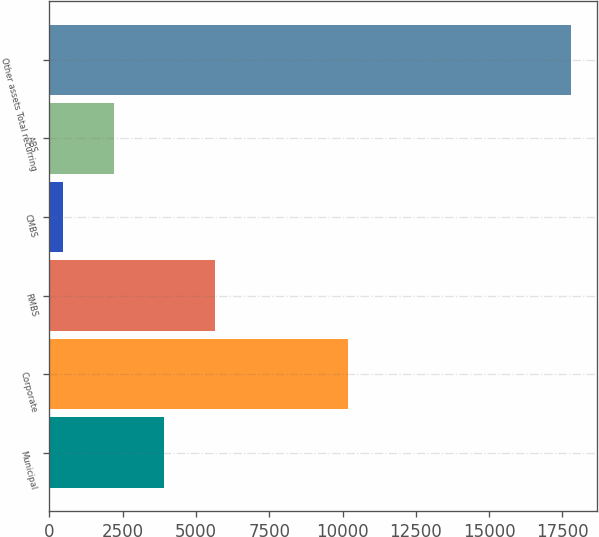<chart> <loc_0><loc_0><loc_500><loc_500><bar_chart><fcel>Municipal<fcel>Corporate<fcel>RMBS<fcel>CMBS<fcel>ABS<fcel>Other assets Total recurring<nl><fcel>3924.2<fcel>10195<fcel>5657.8<fcel>457<fcel>2190.6<fcel>17793<nl></chart> 